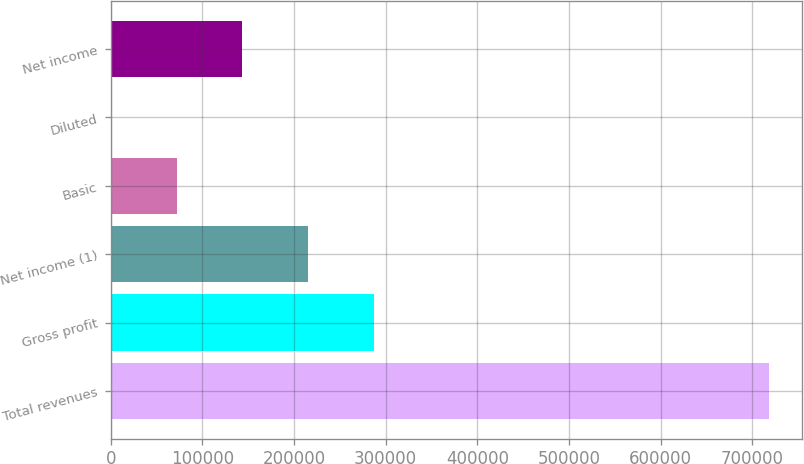<chart> <loc_0><loc_0><loc_500><loc_500><bar_chart><fcel>Total revenues<fcel>Gross profit<fcel>Net income (1)<fcel>Basic<fcel>Diluted<fcel>Net income<nl><fcel>718553<fcel>287422<fcel>215567<fcel>71856.3<fcel>1.11<fcel>143711<nl></chart> 